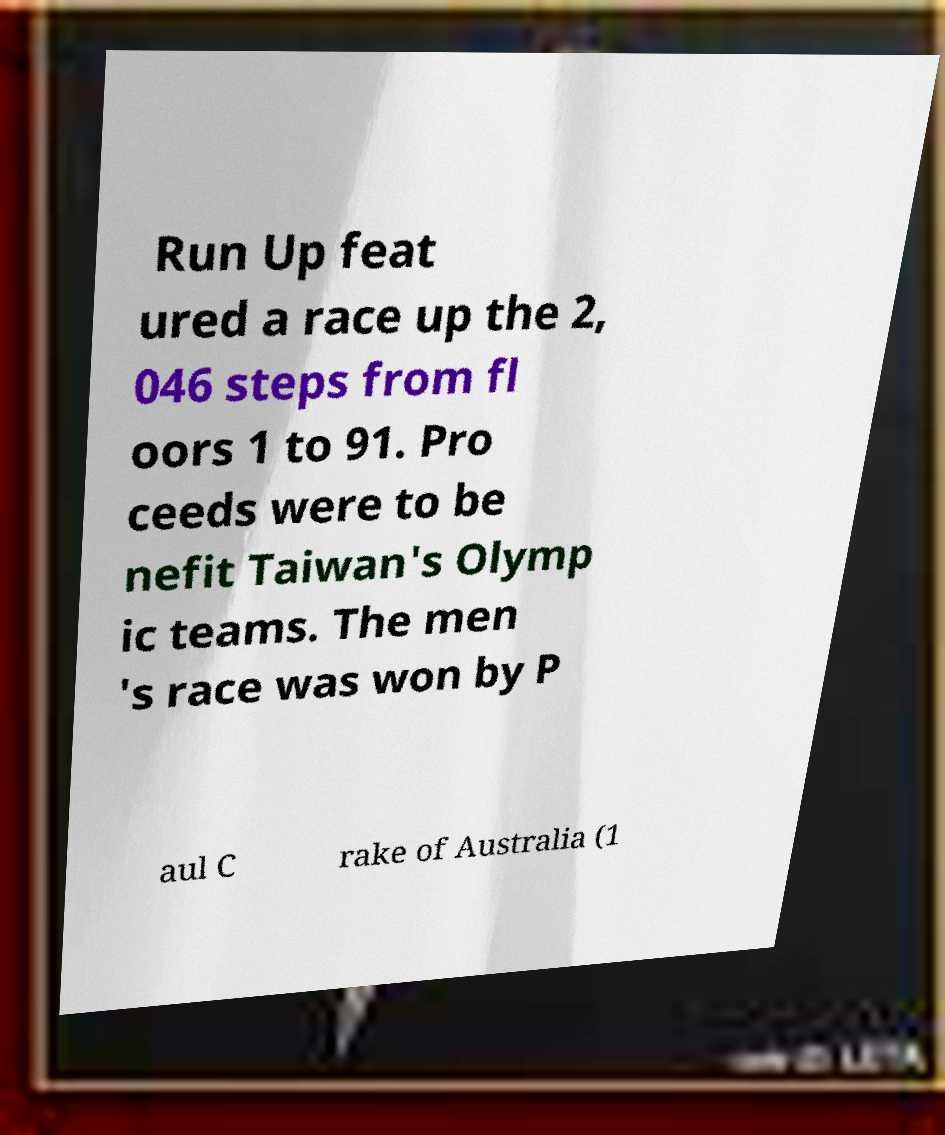What messages or text are displayed in this image? I need them in a readable, typed format. Run Up feat ured a race up the 2, 046 steps from fl oors 1 to 91. Pro ceeds were to be nefit Taiwan's Olymp ic teams. The men 's race was won by P aul C rake of Australia (1 